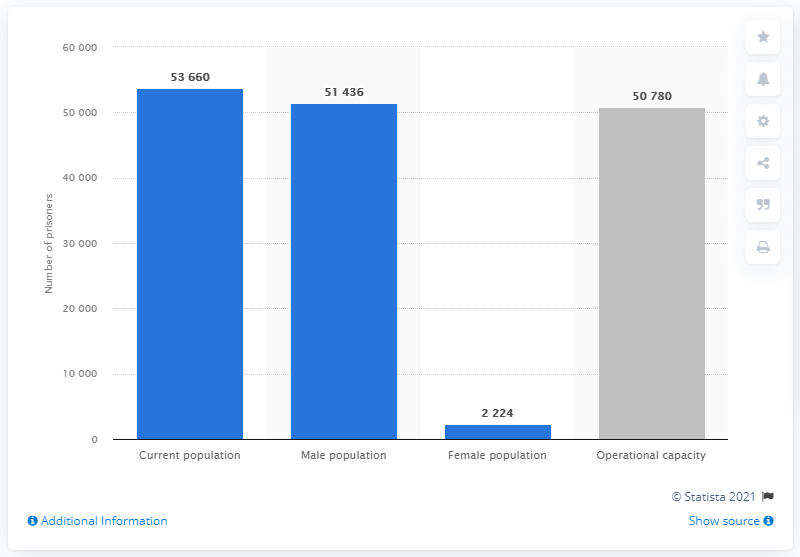Indicate a few pertinent items in this graphic. In 2021, the operational capacity of Italian prisons was reported to be approximately 50,780 individuals. As of May 2021, there were approximately 53,660 prisoners incarcerated in all Italian penal institutions. 